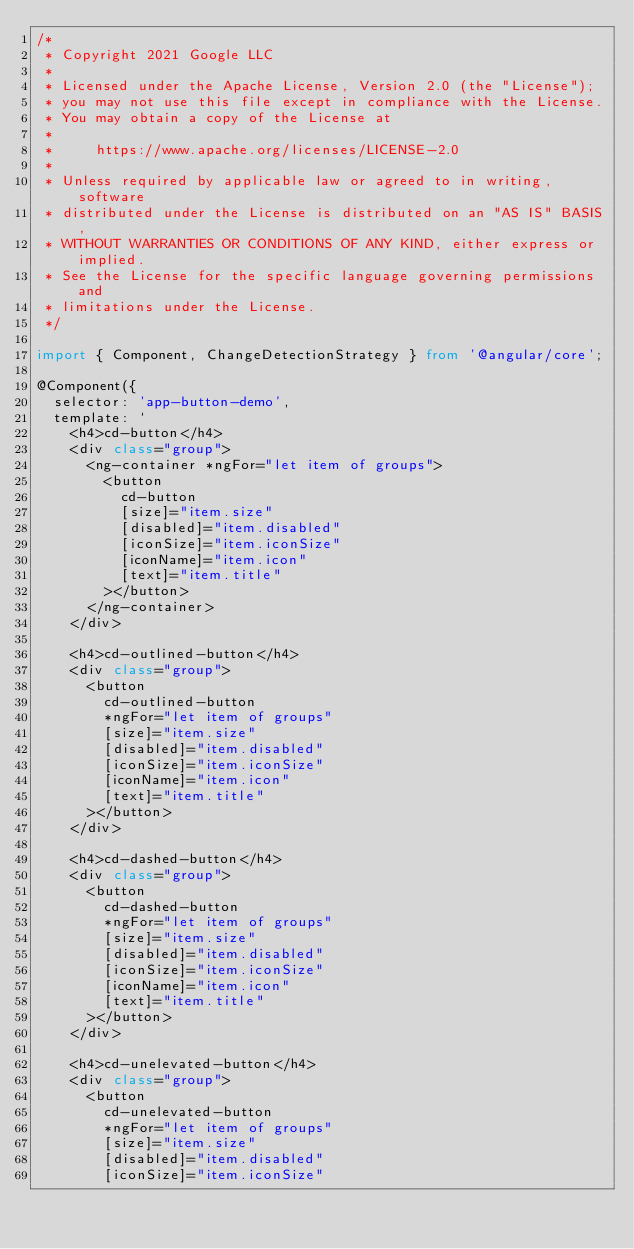Convert code to text. <code><loc_0><loc_0><loc_500><loc_500><_TypeScript_>/*
 * Copyright 2021 Google LLC
 *
 * Licensed under the Apache License, Version 2.0 (the "License");
 * you may not use this file except in compliance with the License.
 * You may obtain a copy of the License at
 *
 *     https://www.apache.org/licenses/LICENSE-2.0
 *
 * Unless required by applicable law or agreed to in writing, software
 * distributed under the License is distributed on an "AS IS" BASIS,
 * WITHOUT WARRANTIES OR CONDITIONS OF ANY KIND, either express or implied.
 * See the License for the specific language governing permissions and
 * limitations under the License.
 */

import { Component, ChangeDetectionStrategy } from '@angular/core';

@Component({
  selector: 'app-button-demo',
  template: `
    <h4>cd-button</h4>
    <div class="group">
      <ng-container *ngFor="let item of groups">
        <button
          cd-button
          [size]="item.size"
          [disabled]="item.disabled"
          [iconSize]="item.iconSize"
          [iconName]="item.icon"
          [text]="item.title"
        ></button>
      </ng-container>
    </div>

    <h4>cd-outlined-button</h4>
    <div class="group">
      <button
        cd-outlined-button
        *ngFor="let item of groups"
        [size]="item.size"
        [disabled]="item.disabled"
        [iconSize]="item.iconSize"
        [iconName]="item.icon"
        [text]="item.title"
      ></button>
    </div>

    <h4>cd-dashed-button</h4>
    <div class="group">
      <button
        cd-dashed-button
        *ngFor="let item of groups"
        [size]="item.size"
        [disabled]="item.disabled"
        [iconSize]="item.iconSize"
        [iconName]="item.icon"
        [text]="item.title"
      ></button>
    </div>

    <h4>cd-unelevated-button</h4>
    <div class="group">
      <button
        cd-unelevated-button
        *ngFor="let item of groups"
        [size]="item.size"
        [disabled]="item.disabled"
        [iconSize]="item.iconSize"</code> 